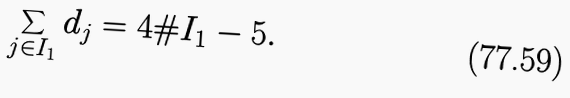<formula> <loc_0><loc_0><loc_500><loc_500>\sum _ { j \in I _ { 1 } } d _ { j } = 4 \# I _ { 1 } - 5 .</formula> 